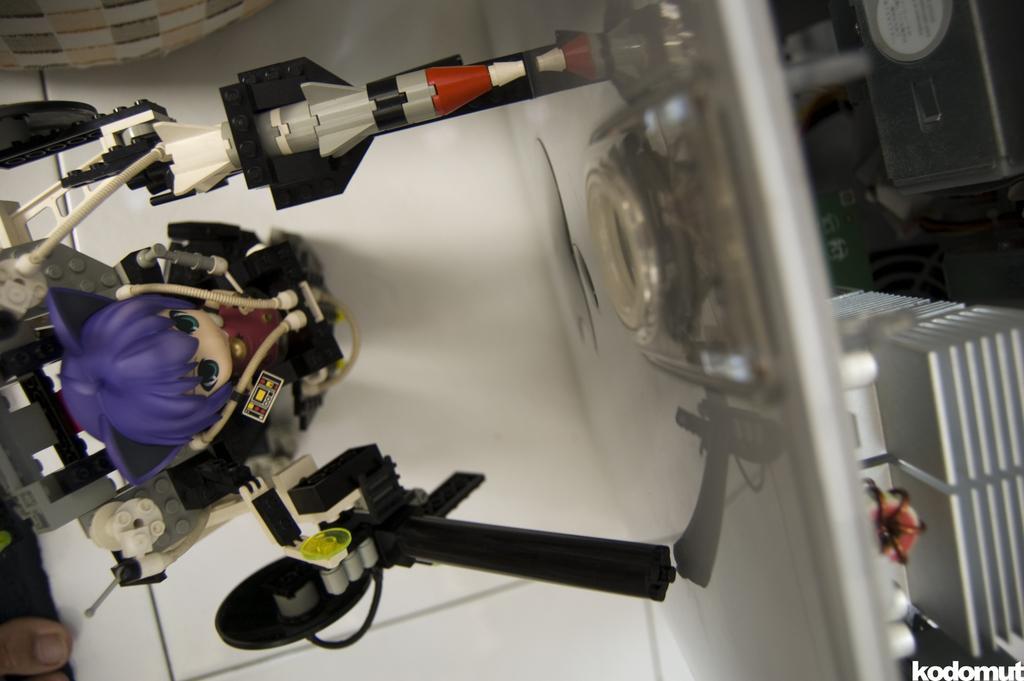Please provide a concise description of this image. In this image there are toys on the surface, there are objects truncated towards the right of the image, there is text at the bottom of the image, there is an object truncated at the top of the image, there is an object truncated towards the left of the image, there are person feet truncated. 